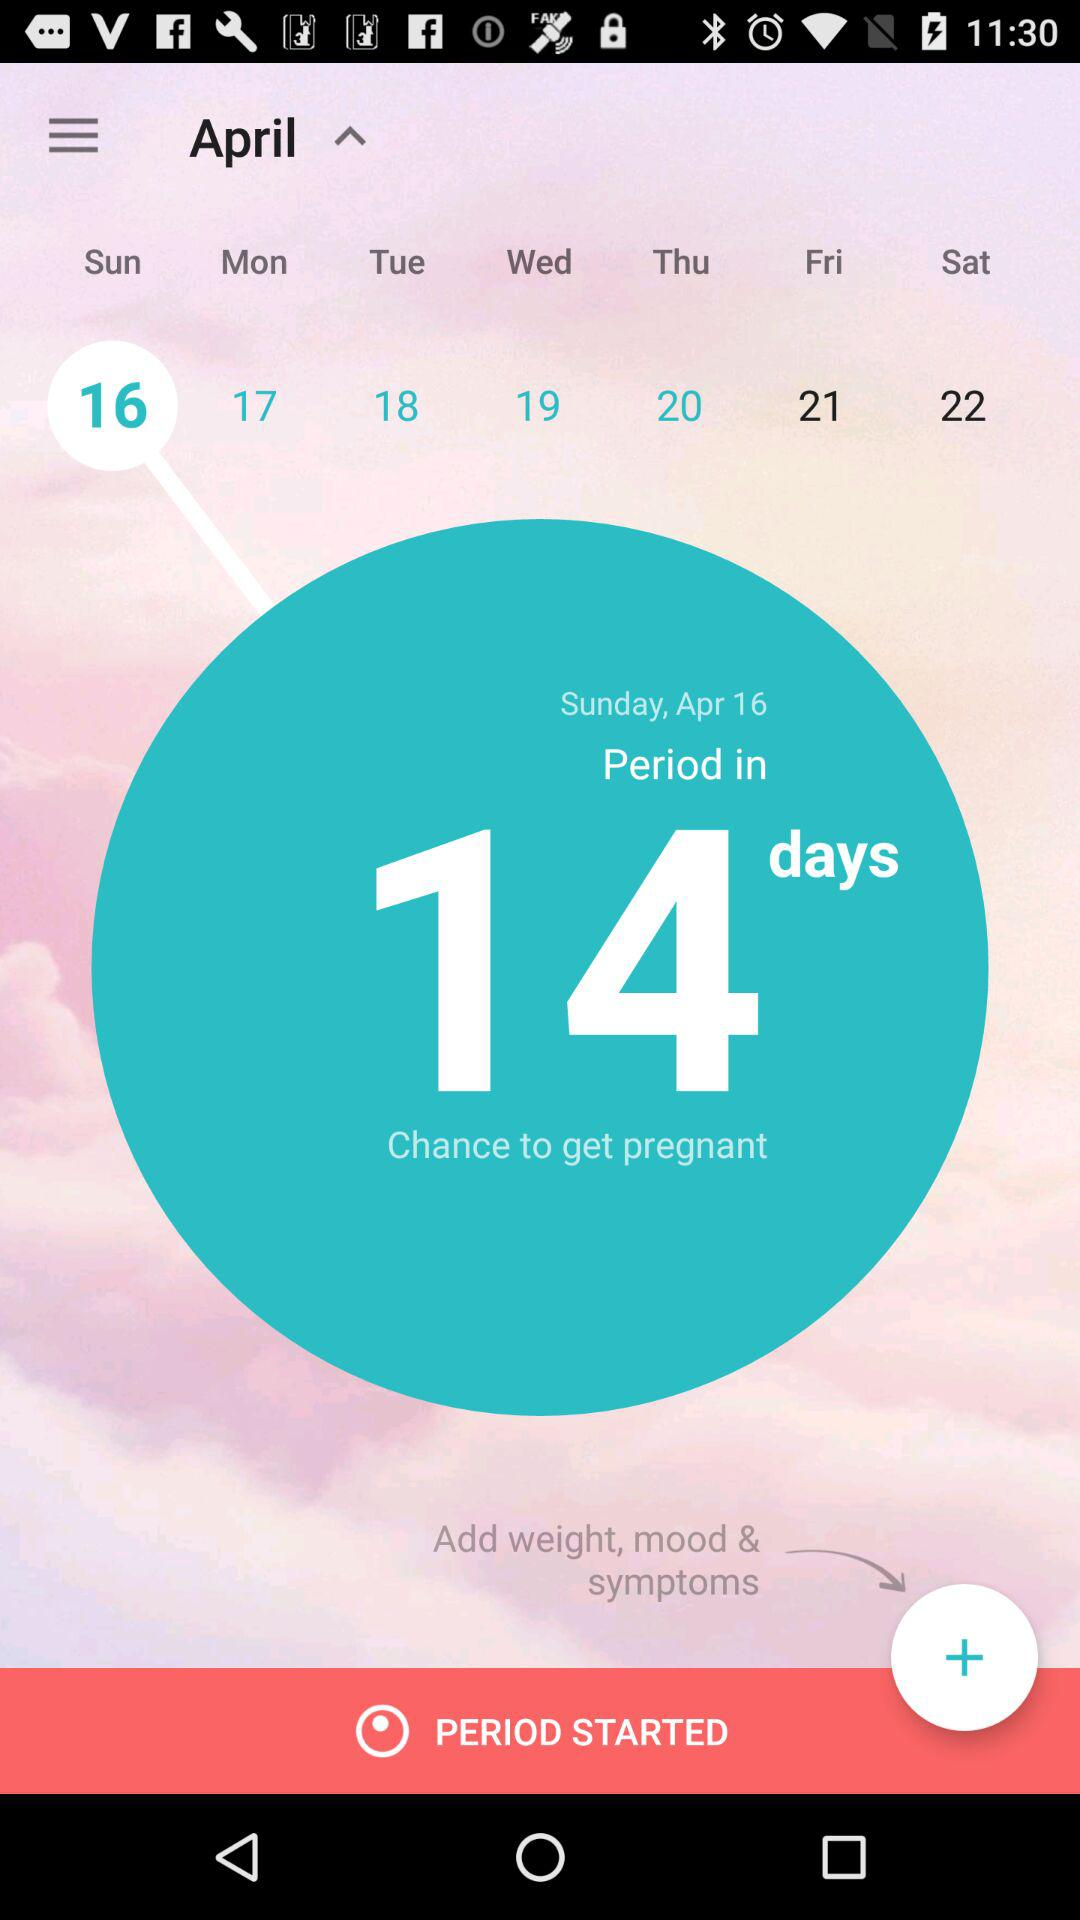What is the selected date? The selected date is Sunday, April 16. 